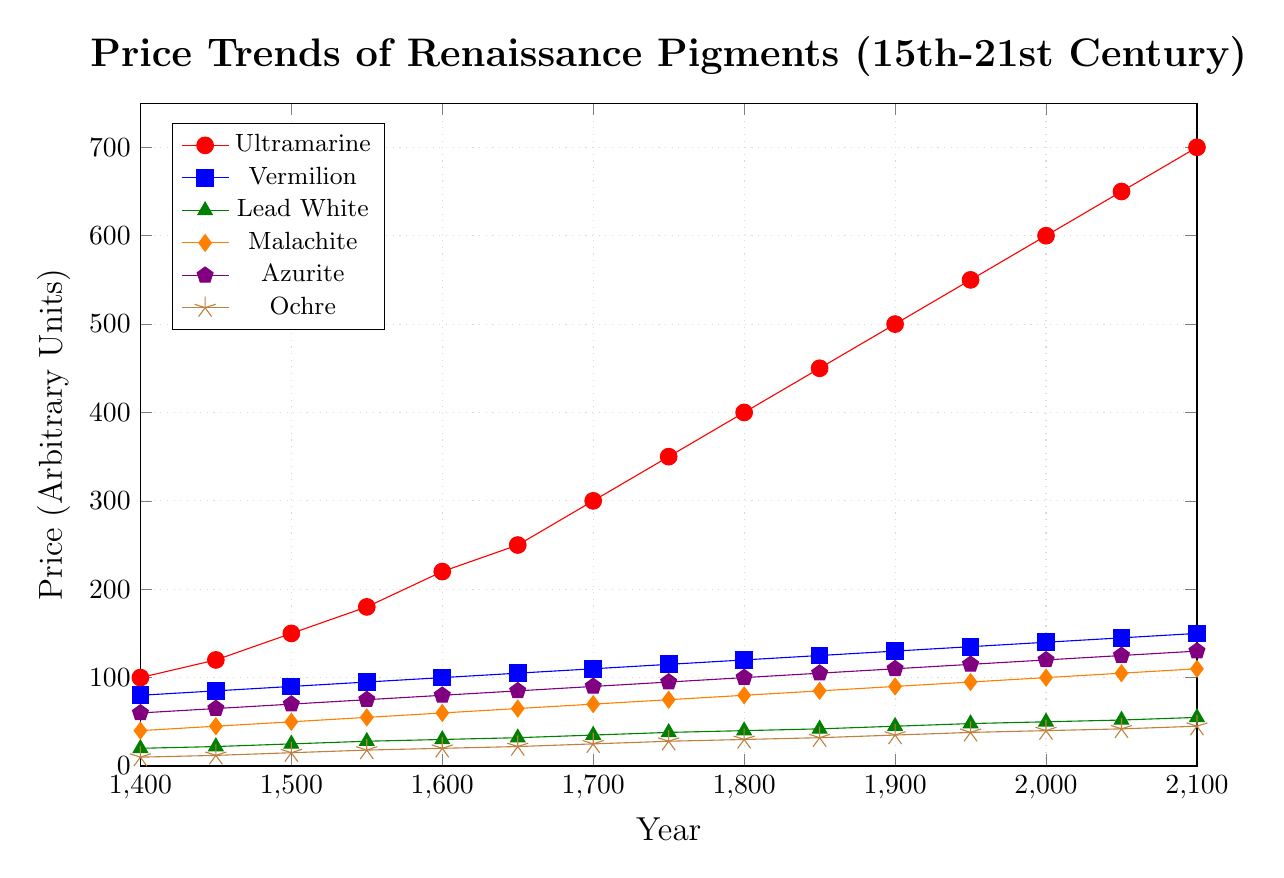What is the price of Ultramarine in the year 1700? Locate the Ultramarine trend line, identified by the color red with circular markers. Follow the trend line to the year 1700 on the x-axis and look at the corresponding y-axis value.
Answer: 300 Which pigment showed the least increase in price from 1400 to 2100? Compare the price increase for each pigment from 1400 to 2100 by calculating the difference for each: Ultramarine (700-100), Vermilion (150-80), Lead White (55-20), Malachite (110-40), Azurite (130-60), and Ochre (45-10). Lead White shows the smallest increase (55-20 = 35).
Answer: Lead White Between 1800 and 1850, which pigment experienced the highest price increase? Calculate the price increase for each pigment between 1800 and 1850: Ultramarine (450-400), Vermilion (125-120), Lead White (42-40), Malachite (85-80), Azurite (105-100), and Ochre (32-30). Ultramarine shows the highest increase (450-400 = 50).
Answer: Ultramarine How does the price of Malachite in 1600 compare to the price of Vermilion in the same year? Locate the trend lines for Malachite (orange with diamond markers) and Vermilion (blue with square markers) at the year 1600. Compare their respective y-axis values. Malachite's price is 60, while Vermilion's is 100.
Answer: Malachite is lower What is the average price of Lead White over the entire period? Find the prices of Lead White for all the years provided: 20, 22, 25, 28, 30, 32, 35, 38, 40, 42, 45, 48, 50, 52, 55. Sum them and then divide by the number of data points (15). Calculation: (20+22+25+28+30+32+35+38+40+42+45+48+50+52+55)/15 = 38.07 (approximately).
Answer: 38.07 Which pigment has the steepest incline in price between 1900 and 1950? Calculate the incline for each pigment in the given period: Ultramarine (550-500), Vermilion (135-130), Lead White (48-45), Malachite (95-90), Azurite (115-110), and Ochre (38-35). Ultramarine has the steepest incline (550-500 = 50).
Answer: Ultramarine In which century did Azurite surpass Malachite in price, and by what margin at the start of that century? Locate the Azurite and Malachite trend lines, identified by violet pentagon markers and orange diamond markers respectively. Determine the century by comparing their prices over the years till Azurite exceeds Malachite. Azurite surpasses Malachite in 1800 (Azureite 100, Malachite 80), making the margin 20 units.
Answer: 19th century, 20 units 